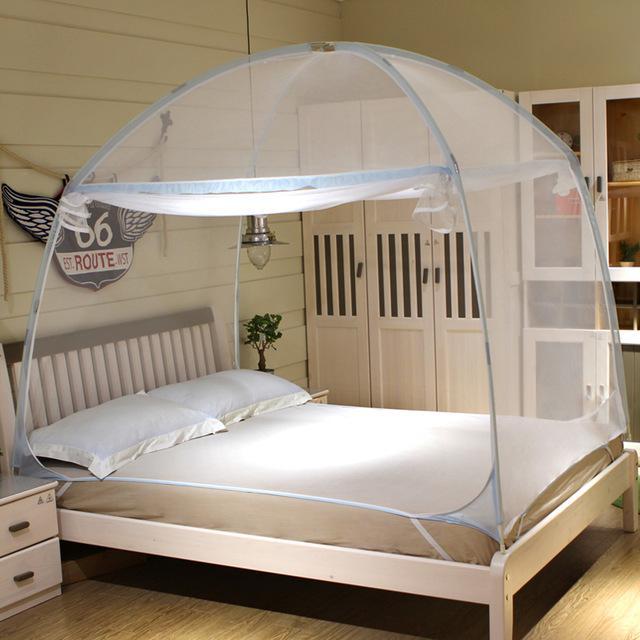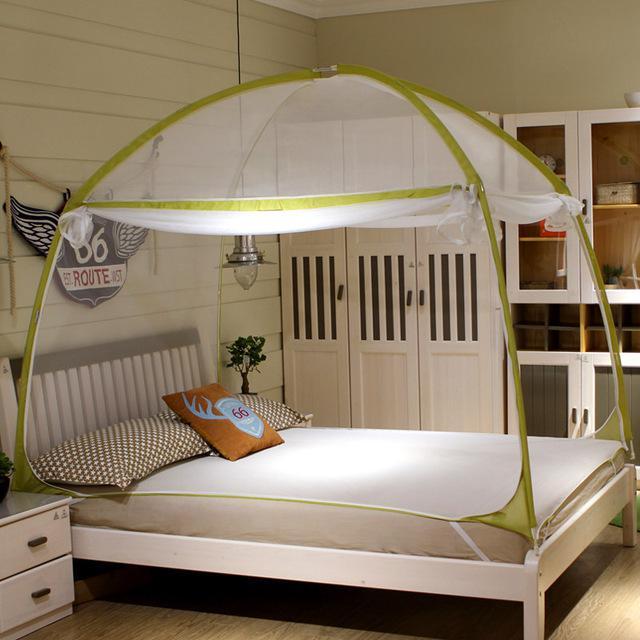The first image is the image on the left, the second image is the image on the right. Considering the images on both sides, is "In the image to the left, the bed canopy is closed." valid? Answer yes or no. No. The first image is the image on the left, the second image is the image on the right. Evaluate the accuracy of this statement regarding the images: "The bed covering in one image is igloo shaped with green ribbing details.". Is it true? Answer yes or no. Yes. 